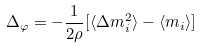Convert formula to latex. <formula><loc_0><loc_0><loc_500><loc_500>\Delta _ { \varphi } = - \frac { 1 } { 2 \rho } [ \langle \Delta m _ { i } ^ { 2 } \rangle - \langle m _ { i } \rangle ]</formula> 